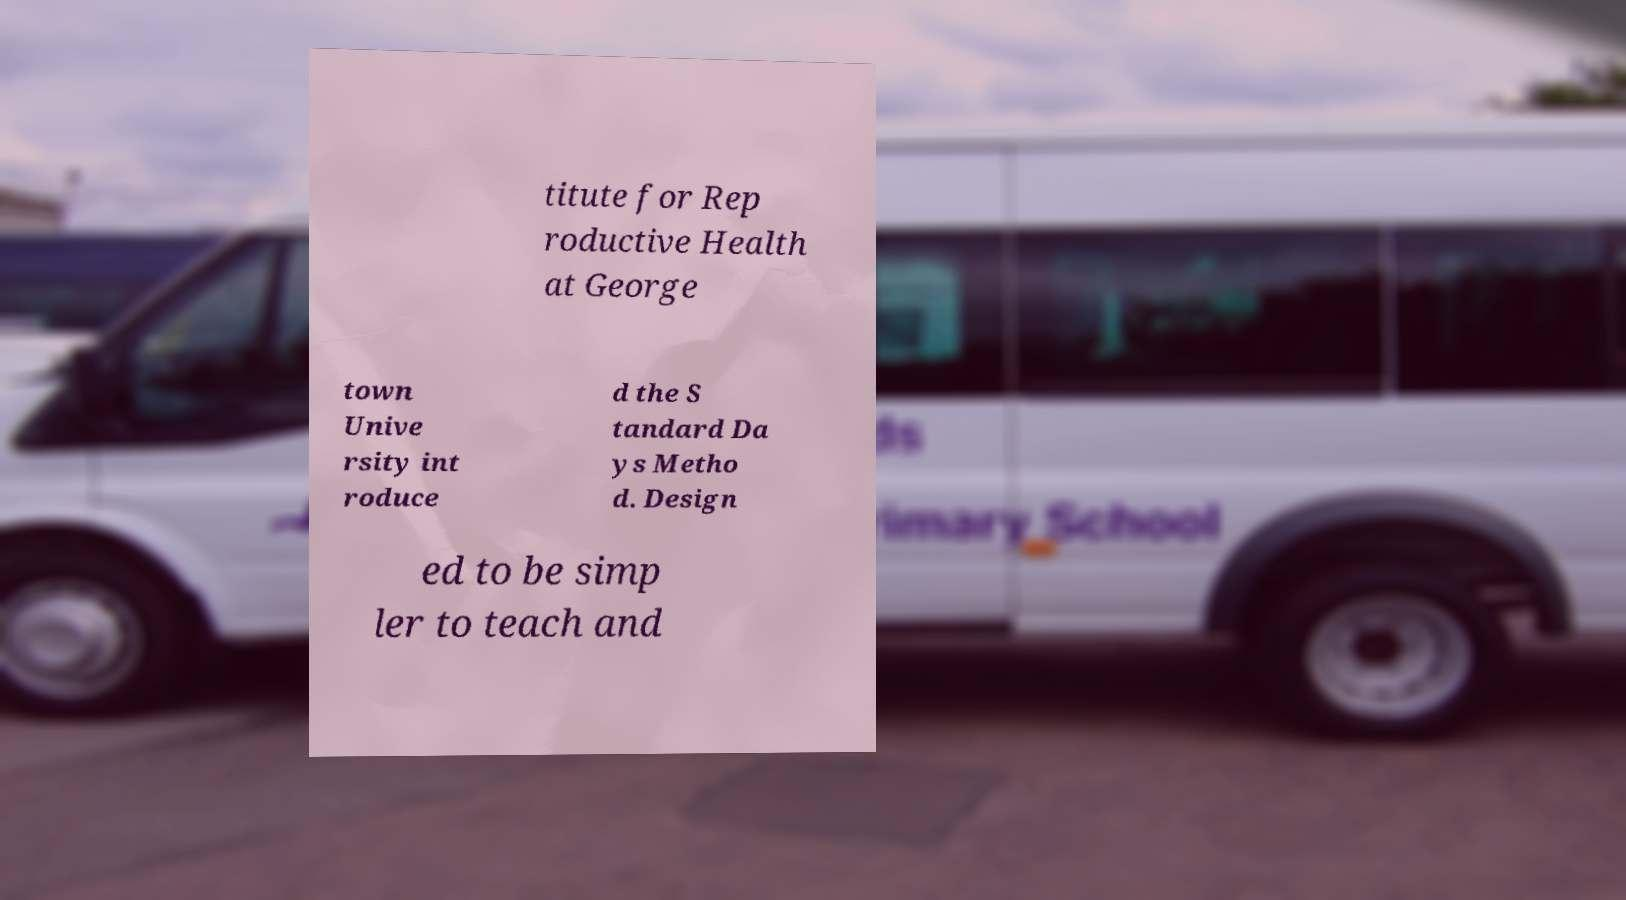I need the written content from this picture converted into text. Can you do that? titute for Rep roductive Health at George town Unive rsity int roduce d the S tandard Da ys Metho d. Design ed to be simp ler to teach and 